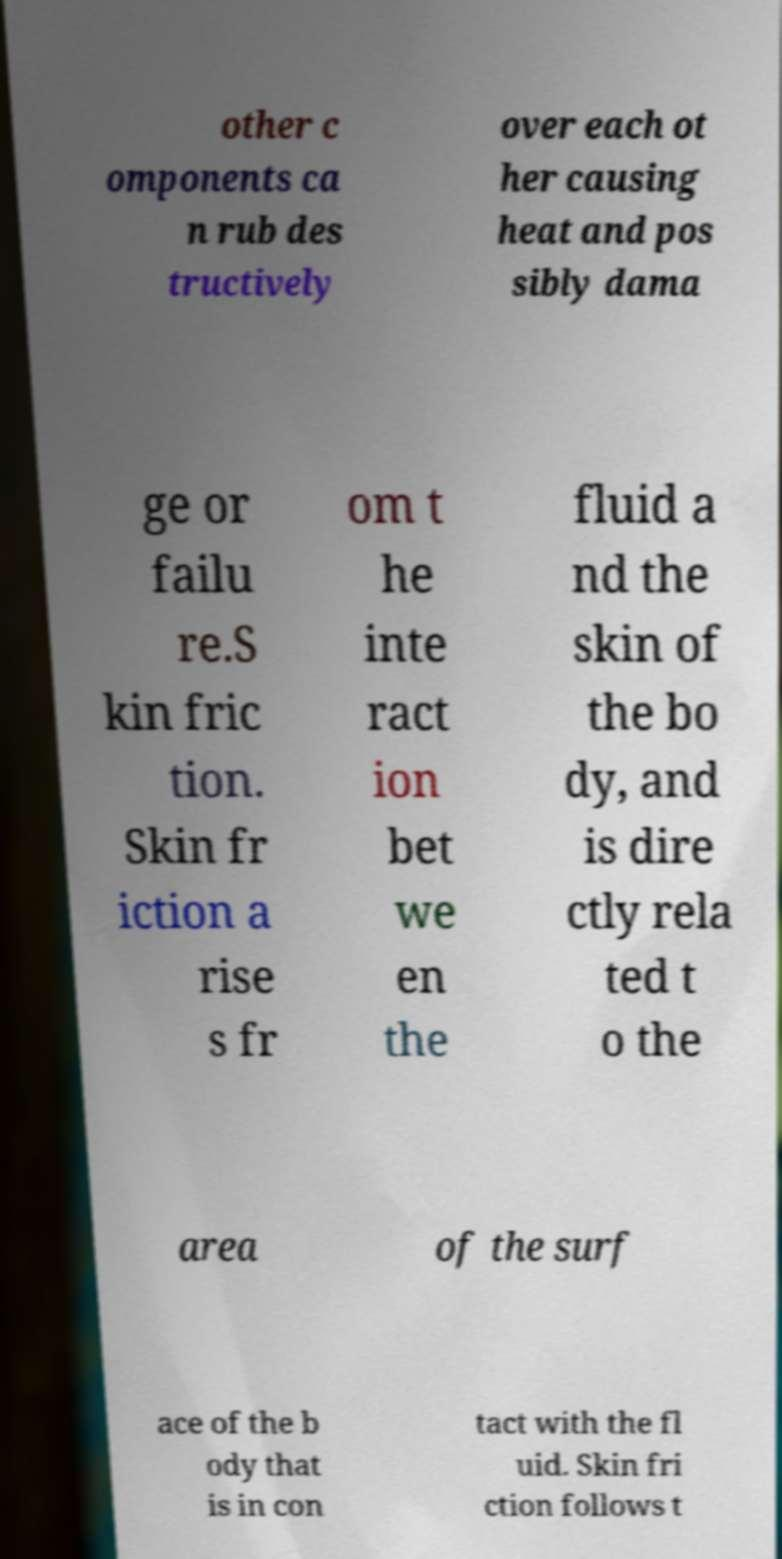I need the written content from this picture converted into text. Can you do that? other c omponents ca n rub des tructively over each ot her causing heat and pos sibly dama ge or failu re.S kin fric tion. Skin fr iction a rise s fr om t he inte ract ion bet we en the fluid a nd the skin of the bo dy, and is dire ctly rela ted t o the area of the surf ace of the b ody that is in con tact with the fl uid. Skin fri ction follows t 